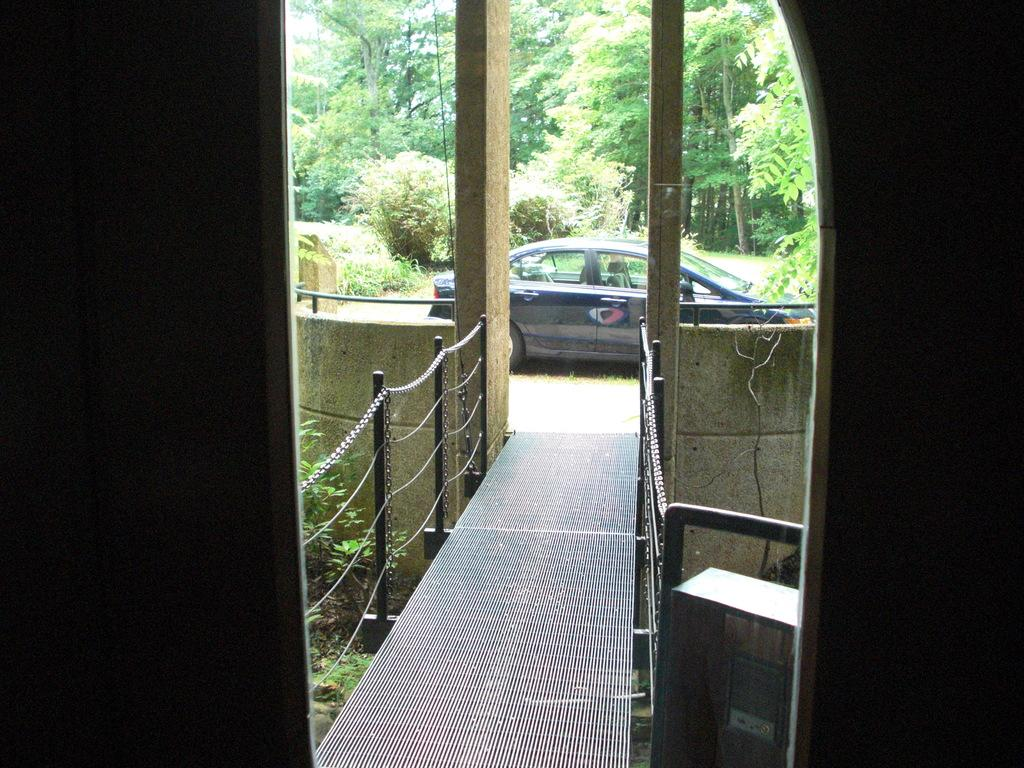What type of structure is in front of the entrance in the image? There is a bridge with a chain fence in front of the entrance in the image. What is parked in front of the fence? A car is parked on the road in front of the fence. What can be seen on the other side of the road? There are trees on the other side of the road. What type of pin is holding the credit card to the club in the image? There is no pin, credit card, or club present in the image. 